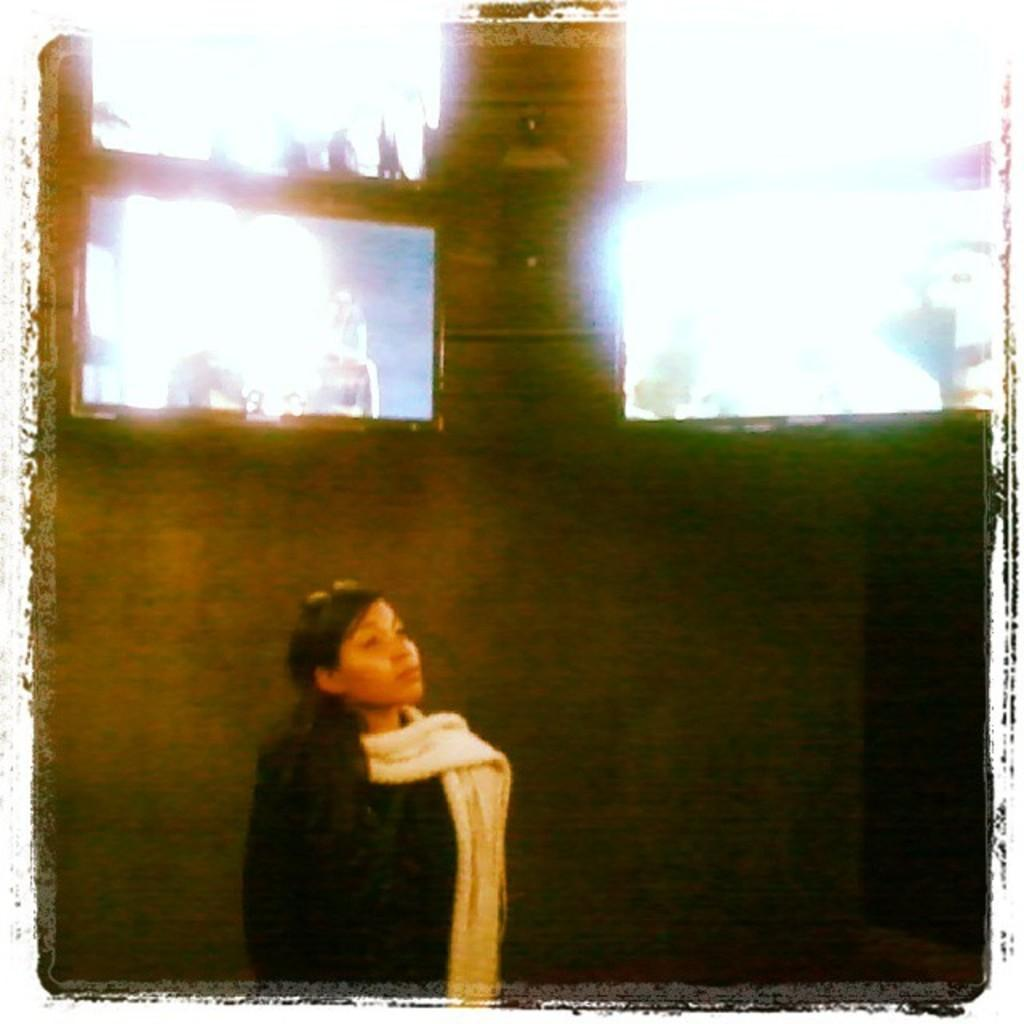Who is present in the image? There is a woman in the image. What is the woman wearing? The woman is wearing a black dress and a white scarf. What can be seen in the background of the image? There are walls visible in the image. What type of furniture is present in the image? There are chairs in the image. What type of thread is being used to decorate the feast in the image? There is no feast or thread present in the image. How many springs are visible on the woman's clothing in the image? There are no springs visible on the woman's clothing in the image. 